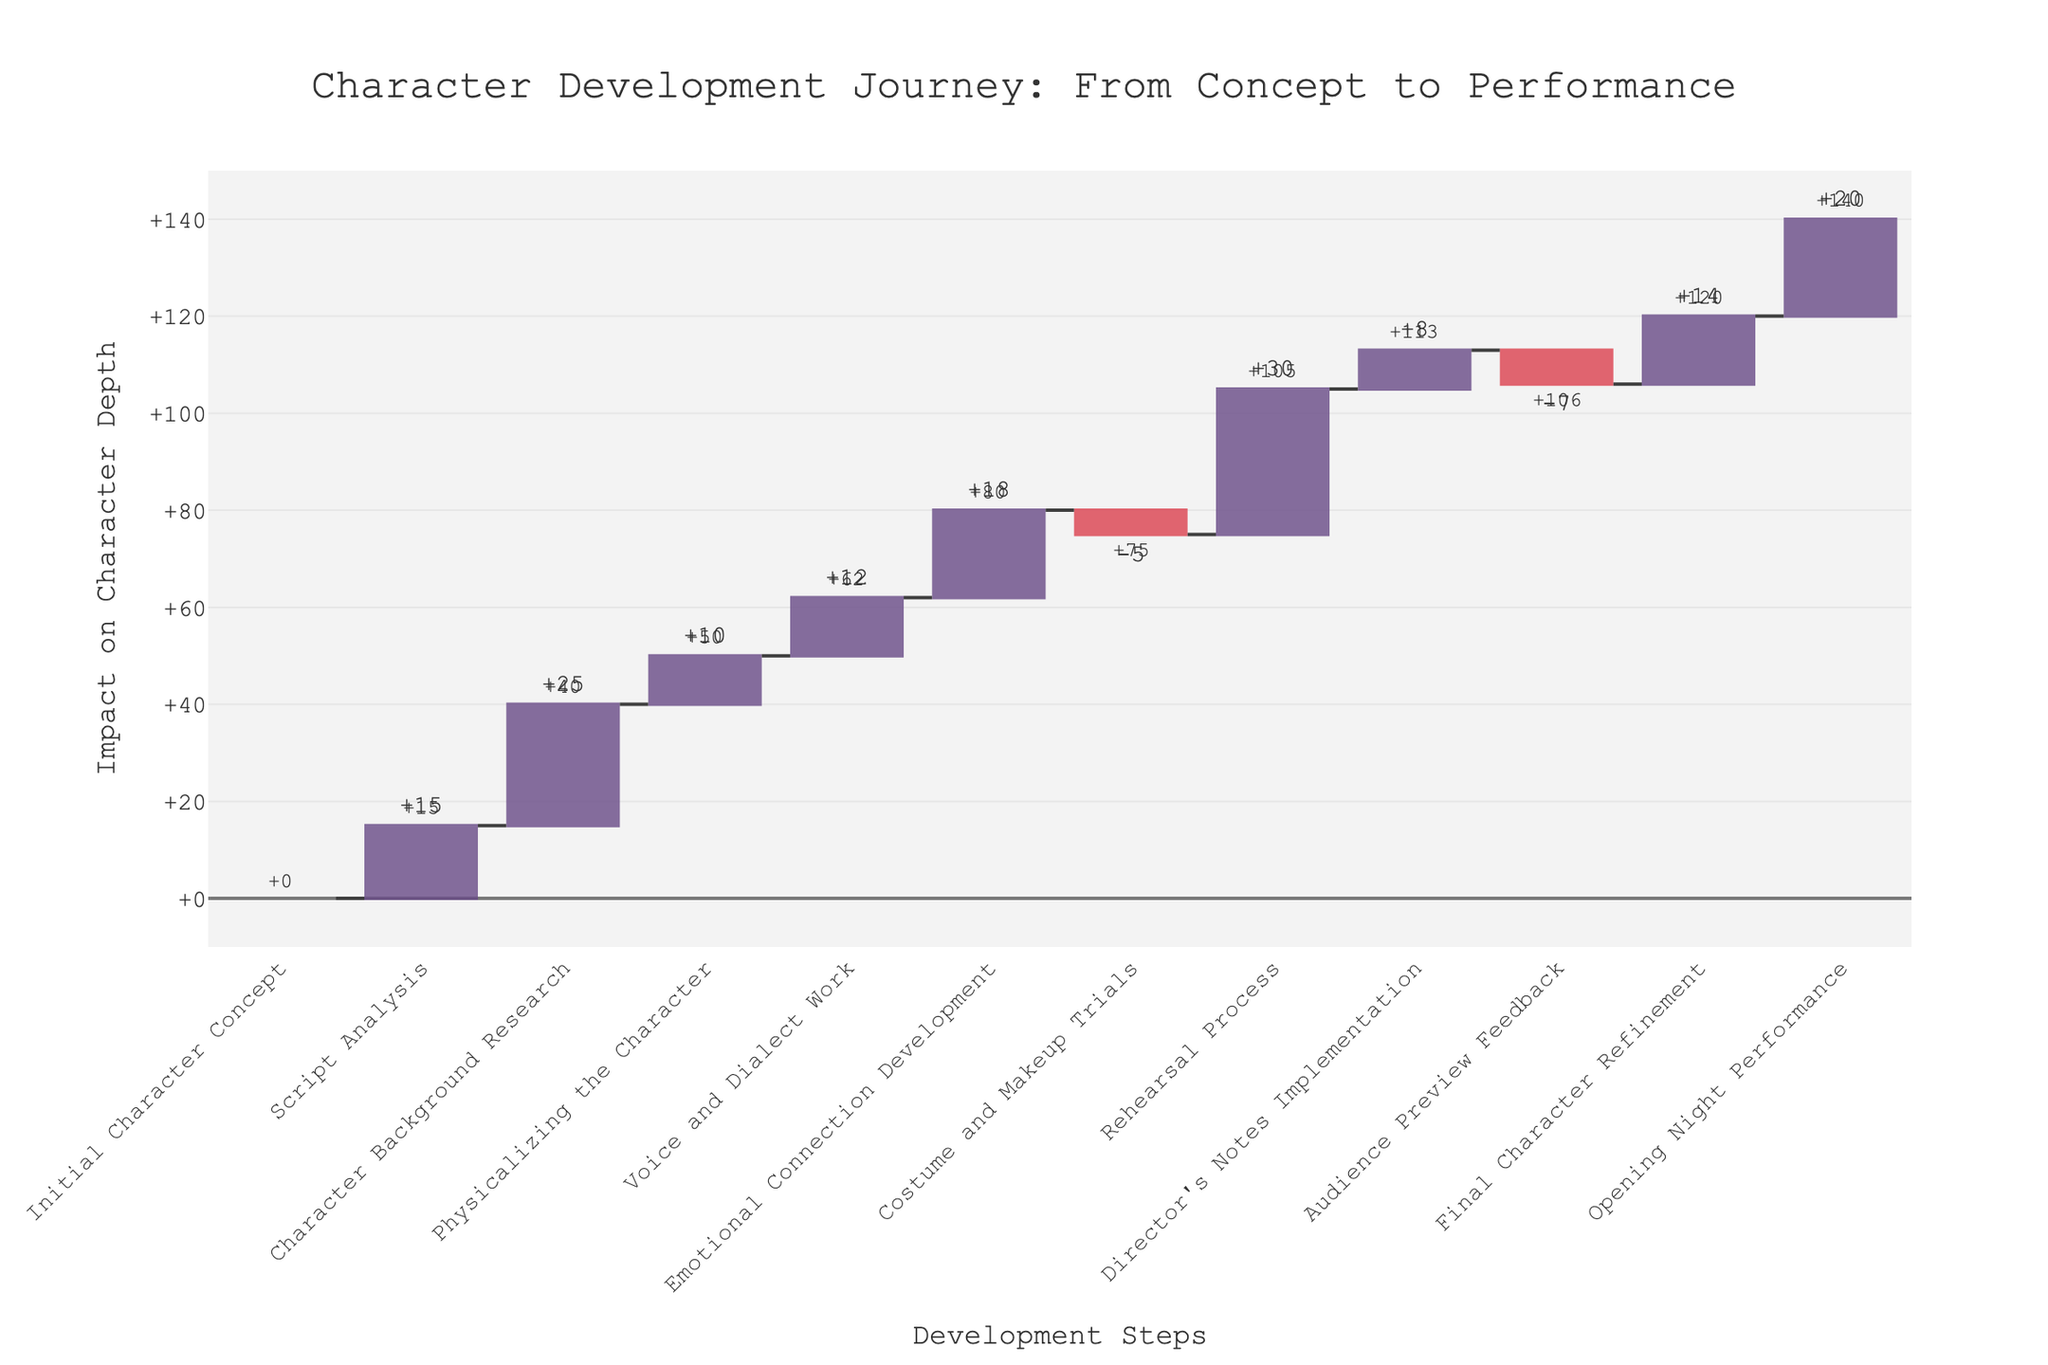What is the title of the figure? The title is typically located at the top of the figure. From the provided data and code, it is clear that the title set for the figure is "Character Development Journey: From Concept to Performance".
Answer: Character Development Journey: From Concept to Performance How many distinct development steps are shown in the figure? We need to count the number of unique entries in the 'Step' column of the data. From the provided data, there are 12 distinct steps listed.
Answer: 12 What step contributes the highest positive impact on character depth? We need to identify the step with the highest positive value in the 'Value' column. In the provided data, "Rehearsal Process" has a value of 30, which is the highest positive impact.
Answer: Rehearsal Process Which step has the greatest negative impact on character depth? We need to identify the step with the lowest value in the 'Value' column. From the provided data, the lowest value is -7 for "Audience Preview Feedback".
Answer: Audience Preview Feedback What is the cumulative impact on character depth after the "Voice and Dialect Work" step? We need to sum the values up to and including the "Voice and Dialect Work" step. The cumulative calculation is: 0 + 15 + 25 + 10 + 12 = 62.
Answer: +62 How does the "Costume and Makeup Trials" step affect the cumulative character depth? We need to find the difference it makes to the cumulative character depth at that point. Just before this step, the cumulative depth is 68 (from summing previous steps). The "Costume and Makeup Trials" step adds -5, resulting in 68 - 5 = 63.
Answer: -5 What is the total cumulative impact by the end of all steps? We sum all the values in the 'Value' column to get the final cumulative impact. Calculation: 0 + 15 + 25 + 10 + 12 + 18 - 5 + 30 + 8 - 7 + 14 + 20 = 140.
Answer: +140 By how much does the "Director's Notes Implementation" step increase the character depth compared to "Rehearsal Process"? The difference between the impact values of these two steps is calculated by subtracting the impact of the "Rehearsal Process" from the "Director's Notes Implementation" (8 - 30).
Answer: -22 How does the "Emotional Connection Development" step compare to the "Voice and Dialect Work" step in terms of impact? We compare the values for these steps in the 'Value' column. "Emotional Connection Development" has a value of 18, while "Voice and Dialect Work" has 12. The difference is: 18 - 12 = 6.
Answer: +6 At which step does the cumulative character depth first exceed 50? We calculate the cumulative depth at each step and find the first instance where it exceeds 50. The cumulative depth exceeds 50 after the “Voice and Dialect Work” step (62).
Answer: Voice and Dialect Work 